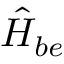<formula> <loc_0><loc_0><loc_500><loc_500>\hat { H } _ { b e }</formula> 